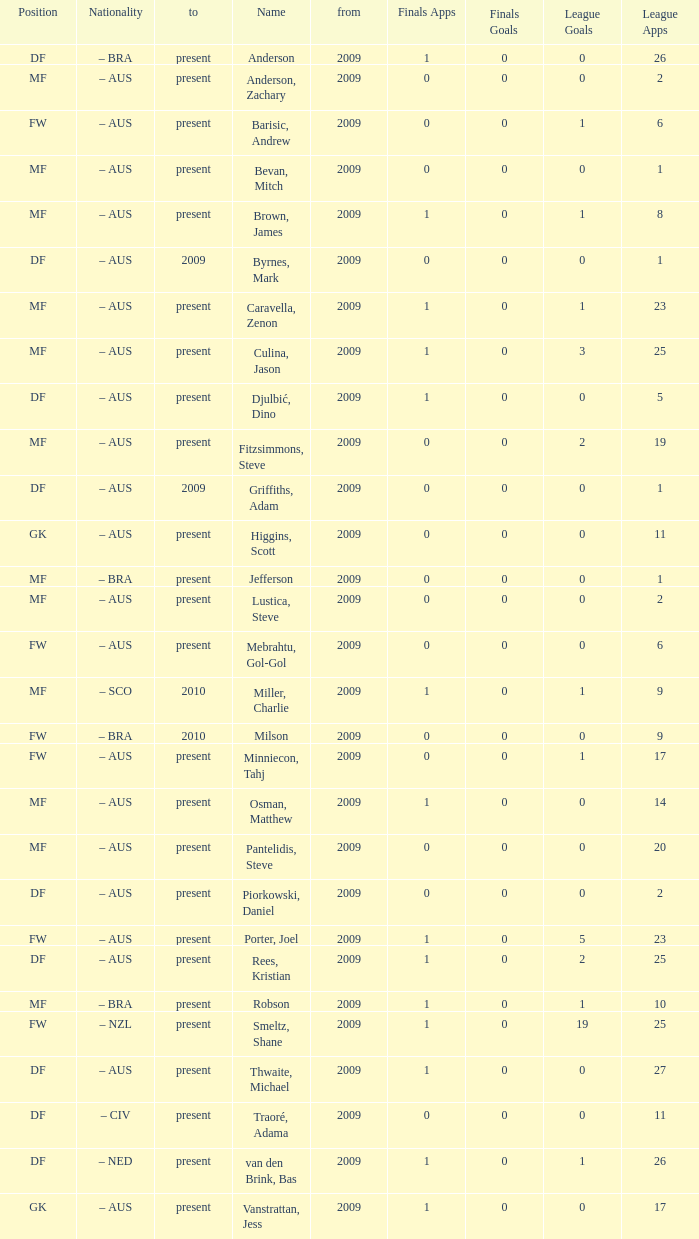Name the mosst finals apps 1.0. 